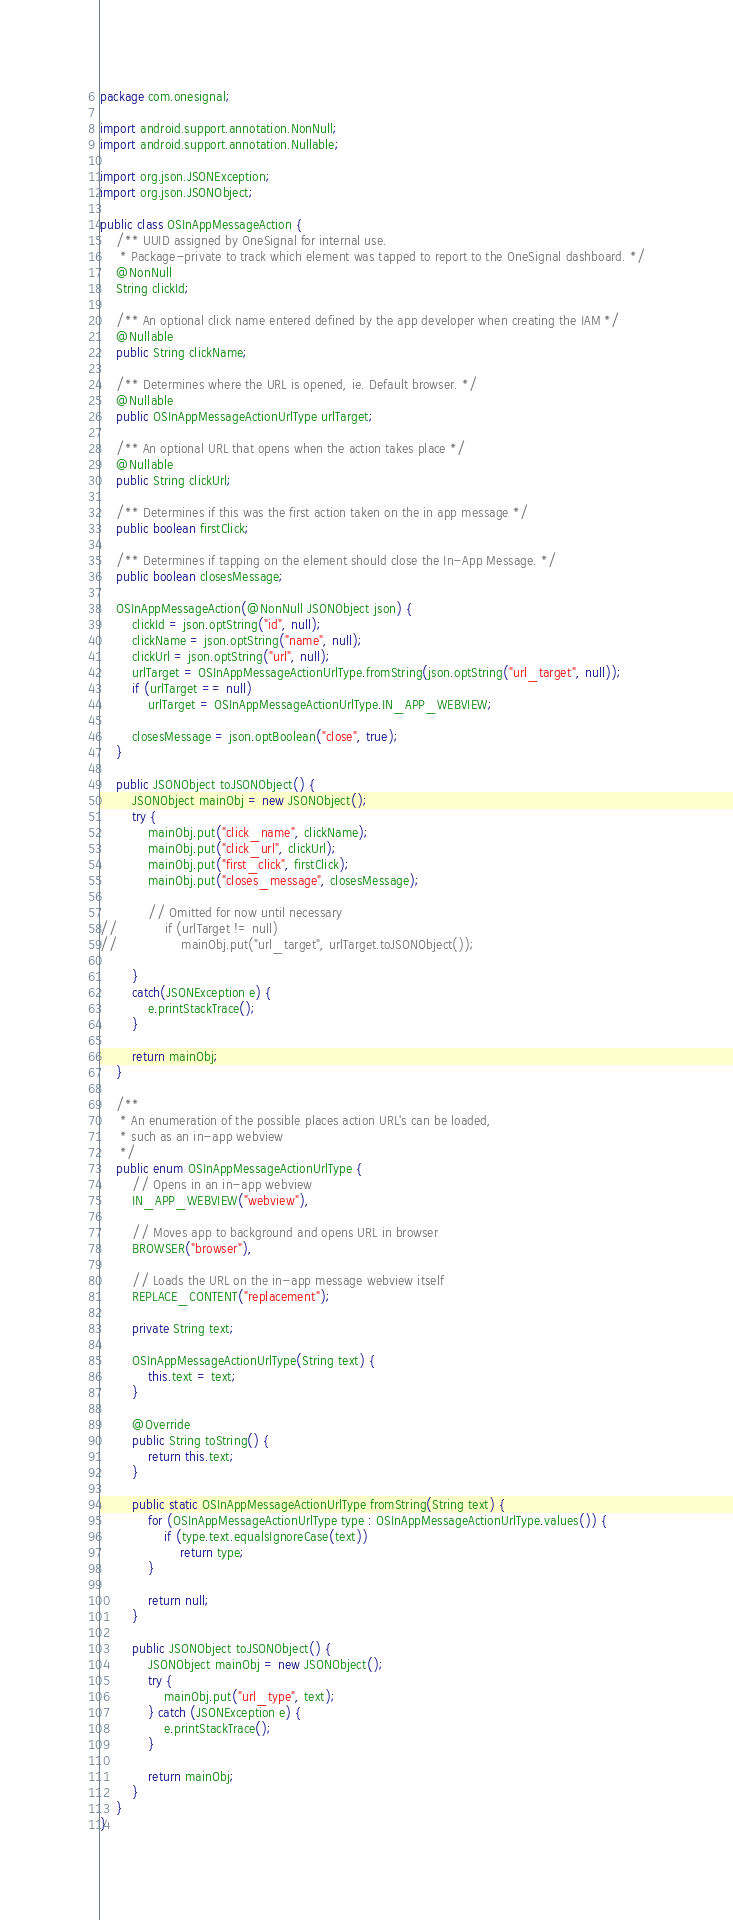<code> <loc_0><loc_0><loc_500><loc_500><_Java_>package com.onesignal;

import android.support.annotation.NonNull;
import android.support.annotation.Nullable;

import org.json.JSONException;
import org.json.JSONObject;

public class OSInAppMessageAction {
    /** UUID assigned by OneSignal for internal use.
     * Package-private to track which element was tapped to report to the OneSignal dashboard. */
    @NonNull
    String clickId;

    /** An optional click name entered defined by the app developer when creating the IAM */
    @Nullable
    public String clickName;

    /** Determines where the URL is opened, ie. Default browser. */
    @Nullable
    public OSInAppMessageActionUrlType urlTarget;

    /** An optional URL that opens when the action takes place */
    @Nullable
    public String clickUrl;

    /** Determines if this was the first action taken on the in app message */
    public boolean firstClick;

    /** Determines if tapping on the element should close the In-App Message. */
    public boolean closesMessage;

    OSInAppMessageAction(@NonNull JSONObject json) {
        clickId = json.optString("id", null);
        clickName = json.optString("name", null);
        clickUrl = json.optString("url", null);
        urlTarget = OSInAppMessageActionUrlType.fromString(json.optString("url_target", null));
        if (urlTarget == null)
            urlTarget = OSInAppMessageActionUrlType.IN_APP_WEBVIEW;

        closesMessage = json.optBoolean("close", true);
    }

    public JSONObject toJSONObject() {
        JSONObject mainObj = new JSONObject();
        try {
            mainObj.put("click_name", clickName);
            mainObj.put("click_url", clickUrl);
            mainObj.put("first_click", firstClick);
            mainObj.put("closes_message", closesMessage);

            // Omitted for now until necessary
//            if (urlTarget != null)
//                mainObj.put("url_target", urlTarget.toJSONObject());

        }
        catch(JSONException e) {
            e.printStackTrace();
        }

        return mainObj;
    }

    /**
     * An enumeration of the possible places action URL's can be loaded,
     * such as an in-app webview
     */
    public enum OSInAppMessageActionUrlType {
        // Opens in an in-app webview
        IN_APP_WEBVIEW("webview"),

        // Moves app to background and opens URL in browser
        BROWSER("browser"),

        // Loads the URL on the in-app message webview itself
        REPLACE_CONTENT("replacement");

        private String text;

        OSInAppMessageActionUrlType(String text) {
            this.text = text;
        }

        @Override
        public String toString() {
            return this.text;
        }

        public static OSInAppMessageActionUrlType fromString(String text) {
            for (OSInAppMessageActionUrlType type : OSInAppMessageActionUrlType.values()) {
                if (type.text.equalsIgnoreCase(text))
                    return type;
            }

            return null;
        }

        public JSONObject toJSONObject() {
            JSONObject mainObj = new JSONObject();
            try {
                mainObj.put("url_type", text);
            } catch (JSONException e) {
                e.printStackTrace();
            }

            return mainObj;
        }
    }
}</code> 